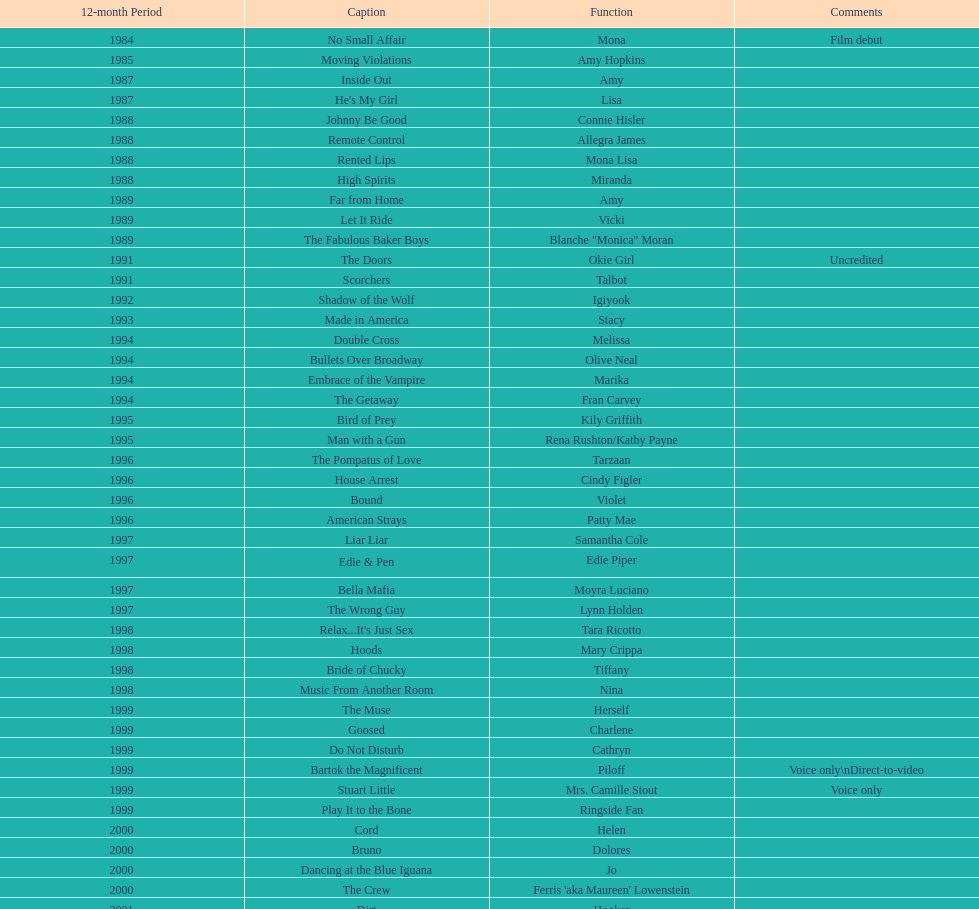How many movies does jennifer tilly play herself? 4. 